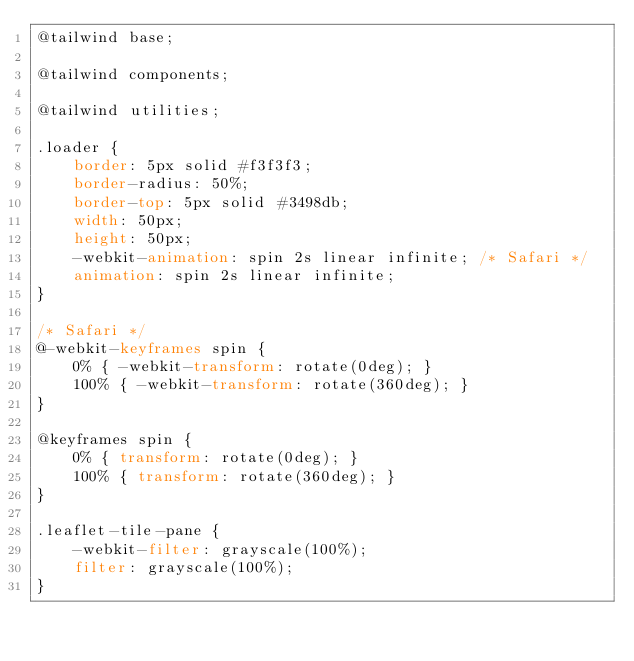Convert code to text. <code><loc_0><loc_0><loc_500><loc_500><_CSS_>@tailwind base;

@tailwind components;

@tailwind utilities;

.loader {
    border: 5px solid #f3f3f3;
    border-radius: 50%;
    border-top: 5px solid #3498db;
    width: 50px;
    height: 50px;
    -webkit-animation: spin 2s linear infinite; /* Safari */
    animation: spin 2s linear infinite;
}

/* Safari */
@-webkit-keyframes spin {
    0% { -webkit-transform: rotate(0deg); }
    100% { -webkit-transform: rotate(360deg); }
}

@keyframes spin {
    0% { transform: rotate(0deg); }
    100% { transform: rotate(360deg); }
}

.leaflet-tile-pane {
    -webkit-filter: grayscale(100%);
    filter: grayscale(100%);
}</code> 